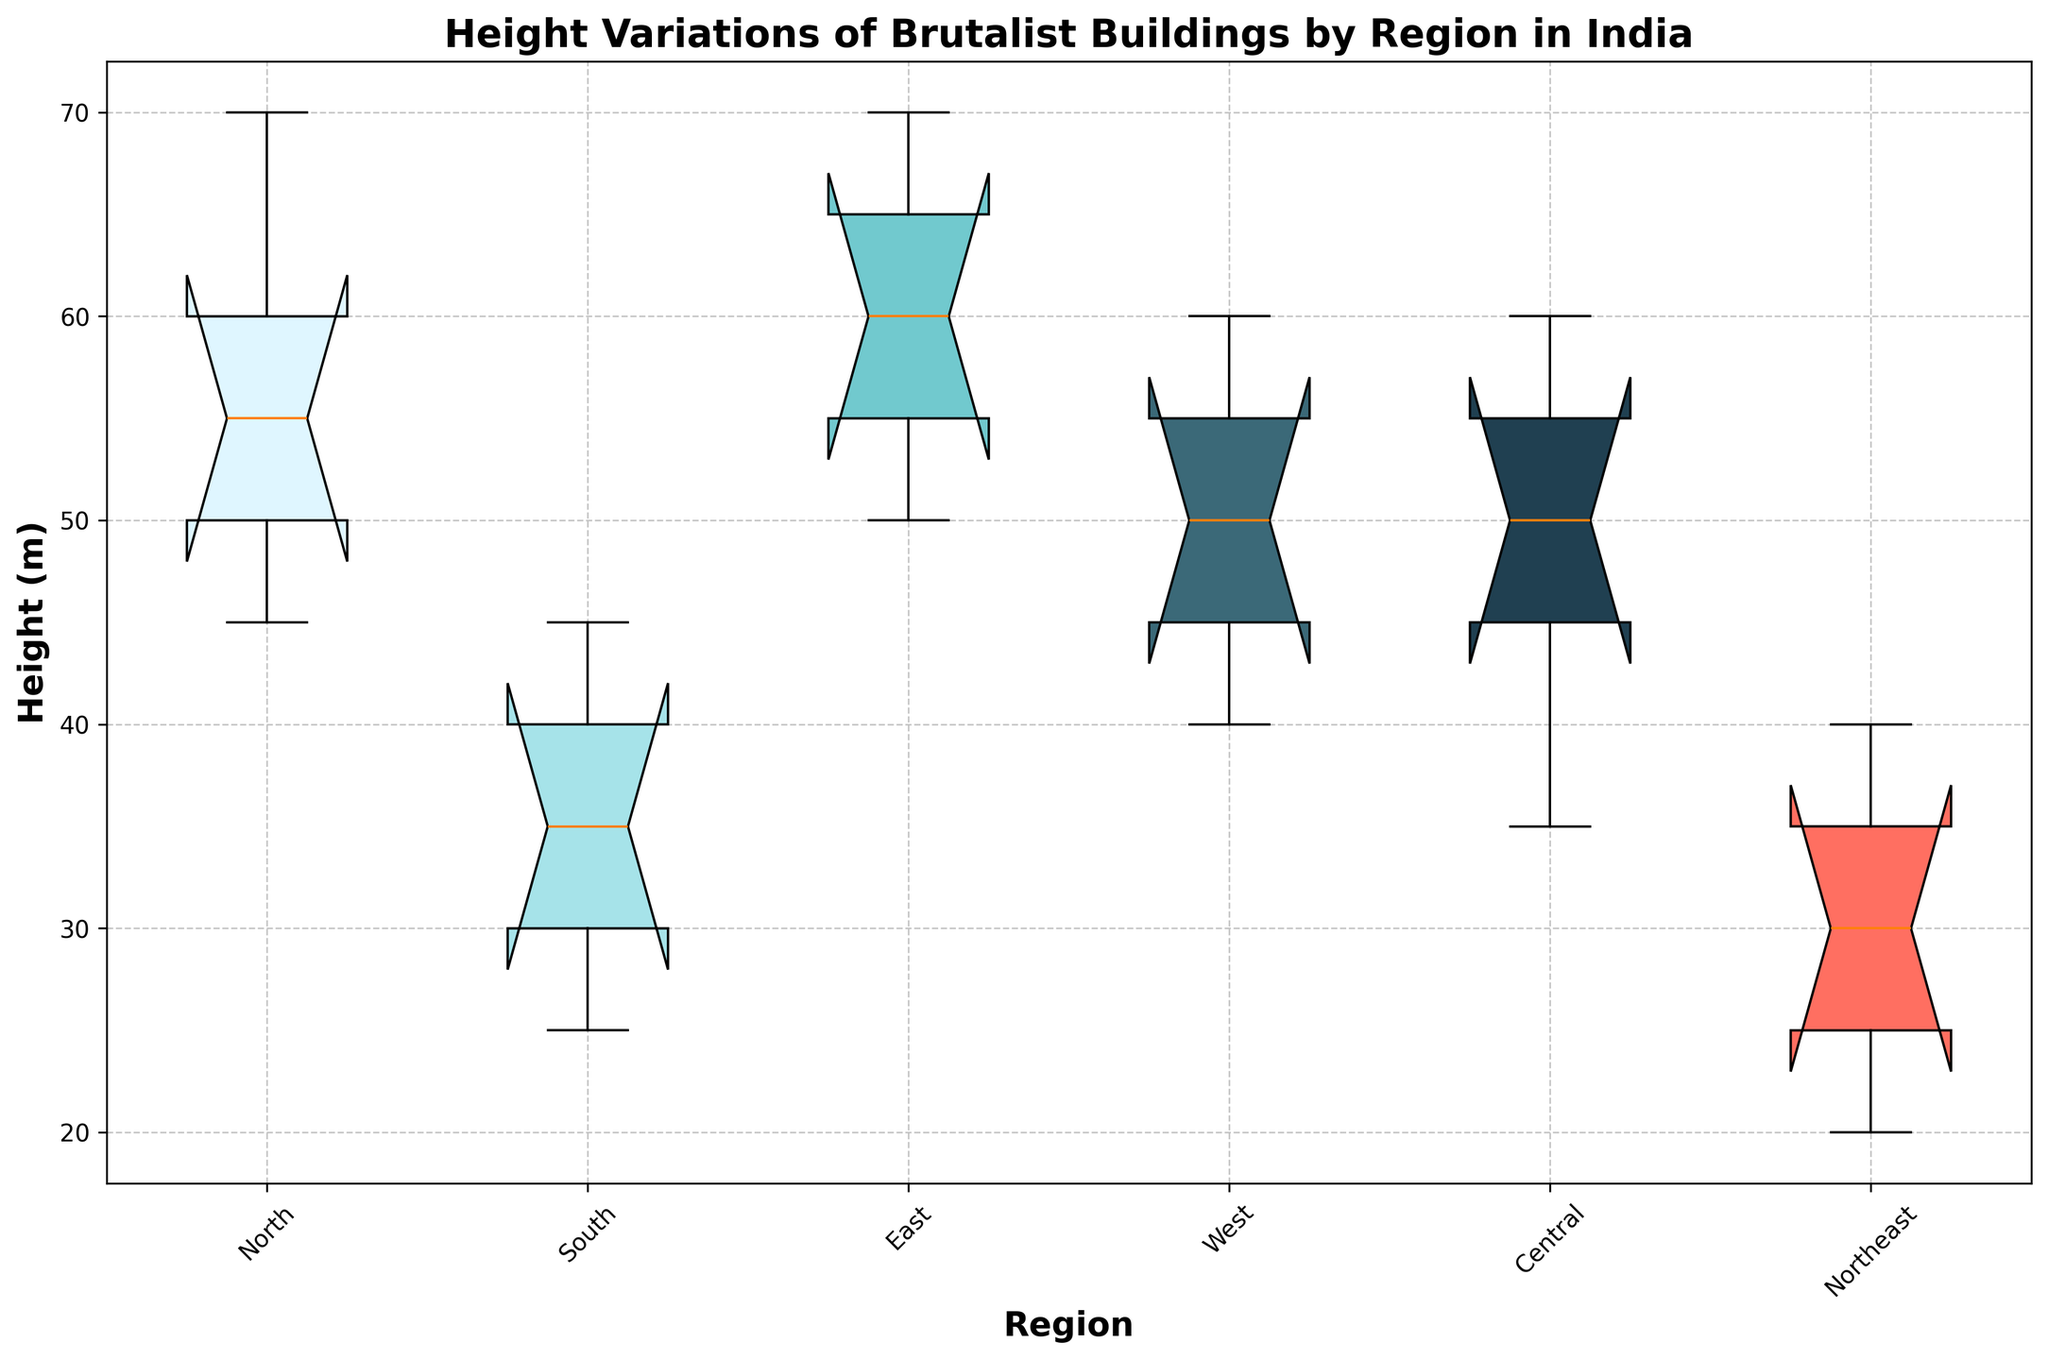What's the median height of Brutalist buildings in the North region? To find the median, arrange the heights in ascending order: [45, 50, 55, 60, 70]. The median value, the middle one, is 55.
Answer: 55 Which region has the greatest variation in the height of its Brutalist buildings? The variation in height can be observed by seeing the box length and the position of the whiskers. The North region has the largest variation as indicated by the spread of its box and whiskers.
Answer: North Which region has the shortest maximum height for Brutalist buildings? Compare the top whiskers of each box. The Northeast region has the shortest maximum height as its top whisker is at 40 meters.
Answer: Northeast What is the interquartile range (IQR) for the South region? IQR is calculated by subtracting the first quartile (Q1) from the third quartile (Q3). From the boxplot, the South region’s Q1 and Q3 can be approximated as 30 and 40 respectively, resulting in an IQR of 40 - 30 = 10 meters.
Answer: 10 Compare the median heights of the East and Central regions. Which is taller? Locate the median lines within the boxes. The East region has a taller median, which appears higher on the Y-axis compared to the Central region.
Answer: East Is there any region where the entire range of building heights is below 50 meters? Inspect the top whiskers for each region. The South and Northeast regions have their top whiskers below 50 meters, indicating their entire height range is below 50 meters.
Answer: South, Northeast What is the range of Brutalist building heights in the Central region? The range is determined by subtracting the minimum height from the maximum height. For the Central region, maximum is 60 meters and minimum is 35 meters, so the range is 60 - 35 = 25 meters.
Answer: 25 Which region has the least variation in building heights? Look for the shortest box and whiskers. The South region shows the least variation as indicated by its shorter box and whiskers.
Answer: South 